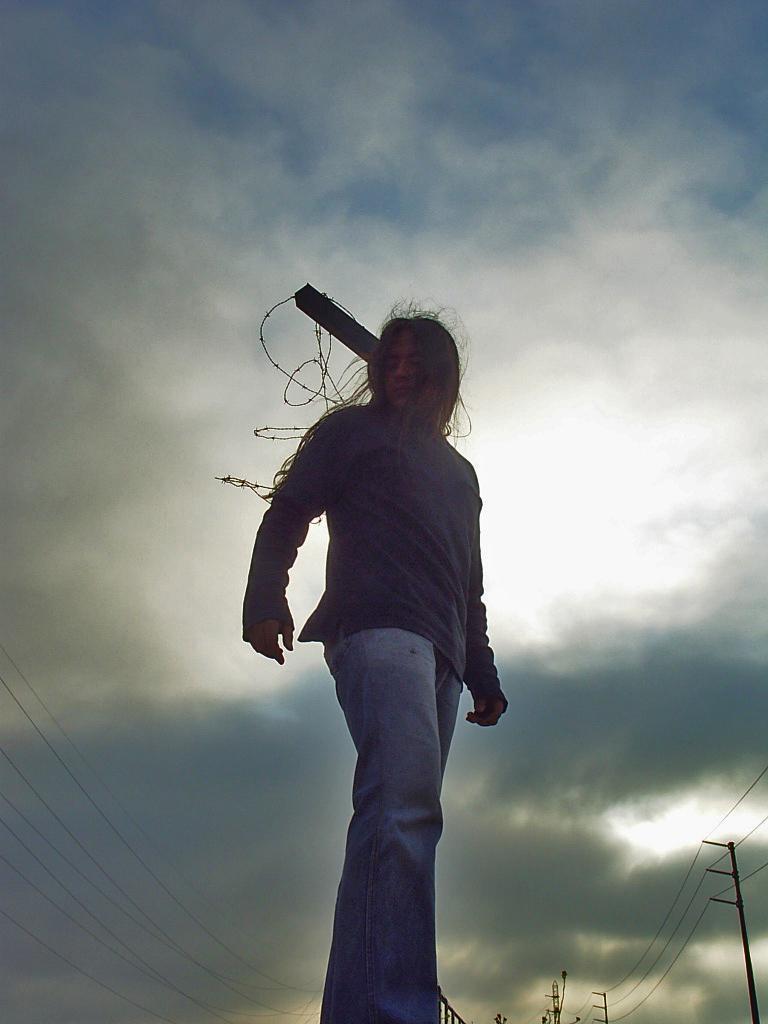Please provide a concise description of this image. In this image we can see a person is standing and he is wearing a blue color dress. In the background of the image we can see the sky. In the foreground of the image we can see current wires. 